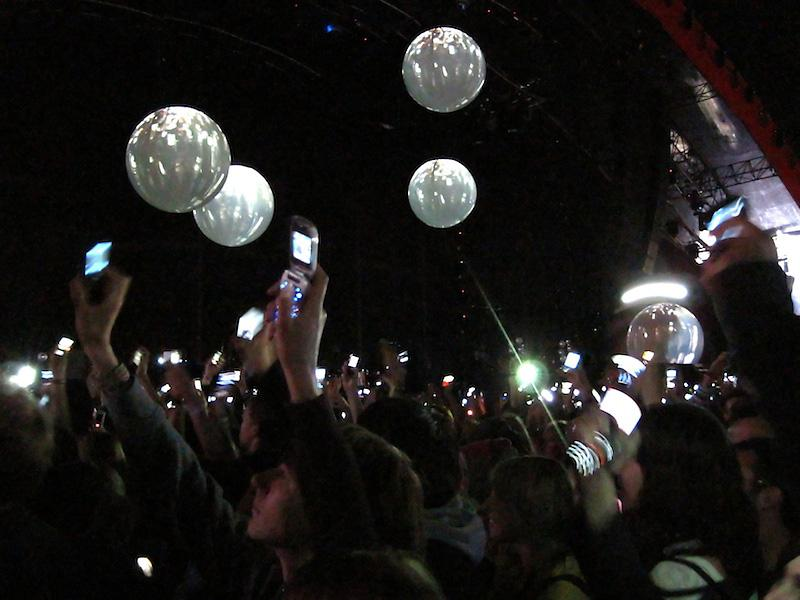Question: who did not put her hands up in the air?
Choices:
A. A white woman.
B. A small child.
C. A man on the left.
D. The back man.
Answer with the letter. Answer: A Question: how many silver balls hang above the crowd?
Choices:
A. Three.
B. Five.
C. Four.
D. Six.
Answer with the letter. Answer: C Question: how do several of the cell phones look?
Choices:
A. Open.
B. Blurred.
C. Turned on.
D. Clear.
Answer with the letter. Answer: B Question: what is floating above the audience?
Choices:
A. Clouds.
B. Birds.
C. Several white balloons.
D. Butterflies.
Answer with the letter. Answer: C Question: what are these people doing?
Choices:
A. Dancing.
B. Celebrating during the night.
C. Sitting.
D. Talking.
Answer with the letter. Answer: B Question: what are the people holding up?
Choices:
A. Signs.
B. Cell phones.
C. Flags.
D. Their hands.
Answer with the letter. Answer: B Question: when is this happening?
Choices:
A. In the morning.
B. Tomorrow.
C. This weekend.
D. At night.
Answer with the letter. Answer: D Question: what are the cell phones doing?
Choices:
A. Ringing.
B. Taking videos.
C. Sending text messages.
D. Taking pictures.
Answer with the letter. Answer: D Question: where are the cellphones?
Choices:
A. In people's hands.
B. On the table.
C. Plugged into the outlet.
D. Up to her ear.
Answer with the letter. Answer: A Question: what color are the floating balls?
Choices:
A. Green and Red.
B. Blue and Yellow.
C. White.
D. Bright neon green.
Answer with the letter. Answer: C Question: who has a flip phone?
Choices:
A. The man in front.
B. The woman.
C. No one.
D. A child.
Answer with the letter. Answer: A Question: what is holding up cell phones?
Choices:
A. People.
B. Tables.
C. Hands.
D. Nothing.
Answer with the letter. Answer: C Question: how is the evening?
Choices:
A. Dark.
B. Quiet.
C. Scary.
D. Bright.
Answer with the letter. Answer: A Question: how many girls don't have a phone lifted?
Choices:
A. Two.
B. Three.
C. Four.
D. One.
Answer with the letter. Answer: D Question: what color is the sky?
Choices:
A. Blue.
B. Orange.
C. Black.
D. Red.
Answer with the letter. Answer: C 